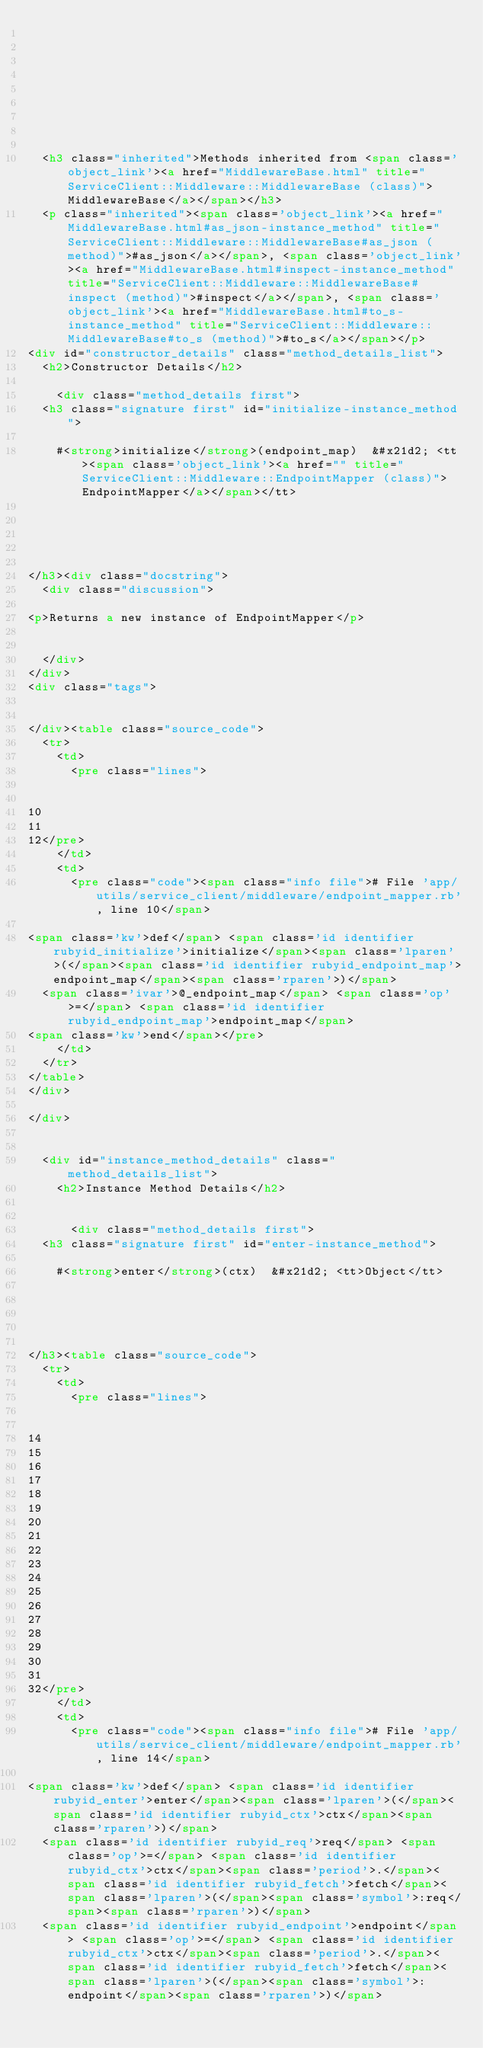<code> <loc_0><loc_0><loc_500><loc_500><_HTML_>
  
  
  
  
  
  
  
  
  <h3 class="inherited">Methods inherited from <span class='object_link'><a href="MiddlewareBase.html" title="ServiceClient::Middleware::MiddlewareBase (class)">MiddlewareBase</a></span></h3>
  <p class="inherited"><span class='object_link'><a href="MiddlewareBase.html#as_json-instance_method" title="ServiceClient::Middleware::MiddlewareBase#as_json (method)">#as_json</a></span>, <span class='object_link'><a href="MiddlewareBase.html#inspect-instance_method" title="ServiceClient::Middleware::MiddlewareBase#inspect (method)">#inspect</a></span>, <span class='object_link'><a href="MiddlewareBase.html#to_s-instance_method" title="ServiceClient::Middleware::MiddlewareBase#to_s (method)">#to_s</a></span></p>
<div id="constructor_details" class="method_details_list">
  <h2>Constructor Details</h2>
  
    <div class="method_details first">
  <h3 class="signature first" id="initialize-instance_method">
  
    #<strong>initialize</strong>(endpoint_map)  &#x21d2; <tt><span class='object_link'><a href="" title="ServiceClient::Middleware::EndpointMapper (class)">EndpointMapper</a></span></tt> 
  

  

  
</h3><div class="docstring">
  <div class="discussion">
    
<p>Returns a new instance of EndpointMapper</p>


  </div>
</div>
<div class="tags">
  

</div><table class="source_code">
  <tr>
    <td>
      <pre class="lines">


10
11
12</pre>
    </td>
    <td>
      <pre class="code"><span class="info file"># File 'app/utils/service_client/middleware/endpoint_mapper.rb', line 10</span>

<span class='kw'>def</span> <span class='id identifier rubyid_initialize'>initialize</span><span class='lparen'>(</span><span class='id identifier rubyid_endpoint_map'>endpoint_map</span><span class='rparen'>)</span>
  <span class='ivar'>@_endpoint_map</span> <span class='op'>=</span> <span class='id identifier rubyid_endpoint_map'>endpoint_map</span>
<span class='kw'>end</span></pre>
    </td>
  </tr>
</table>
</div>
  
</div>


  <div id="instance_method_details" class="method_details_list">
    <h2>Instance Method Details</h2>

    
      <div class="method_details first">
  <h3 class="signature first" id="enter-instance_method">
  
    #<strong>enter</strong>(ctx)  &#x21d2; <tt>Object</tt> 
  

  

  
</h3><table class="source_code">
  <tr>
    <td>
      <pre class="lines">


14
15
16
17
18
19
20
21
22
23
24
25
26
27
28
29
30
31
32</pre>
    </td>
    <td>
      <pre class="code"><span class="info file"># File 'app/utils/service_client/middleware/endpoint_mapper.rb', line 14</span>

<span class='kw'>def</span> <span class='id identifier rubyid_enter'>enter</span><span class='lparen'>(</span><span class='id identifier rubyid_ctx'>ctx</span><span class='rparen'>)</span>
  <span class='id identifier rubyid_req'>req</span> <span class='op'>=</span> <span class='id identifier rubyid_ctx'>ctx</span><span class='period'>.</span><span class='id identifier rubyid_fetch'>fetch</span><span class='lparen'>(</span><span class='symbol'>:req</span><span class='rparen'>)</span>
  <span class='id identifier rubyid_endpoint'>endpoint</span> <span class='op'>=</span> <span class='id identifier rubyid_ctx'>ctx</span><span class='period'>.</span><span class='id identifier rubyid_fetch'>fetch</span><span class='lparen'>(</span><span class='symbol'>:endpoint</span><span class='rparen'>)</span>
</code> 